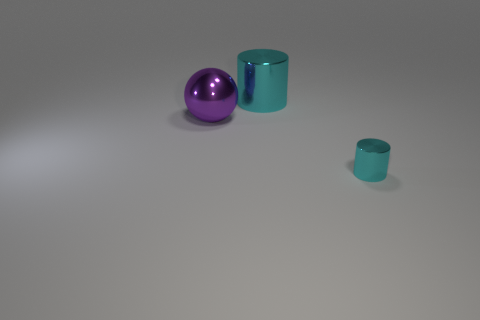Can you tell me the colors of the objects and how their sizes compare to each other? Certainly! There are three objects in the image. From left to right, we have a small purple sphere, a large teal cylinder, and a small teal cylinder. The large cylinder is the tallest object, while the two smaller objects are similar in height. 